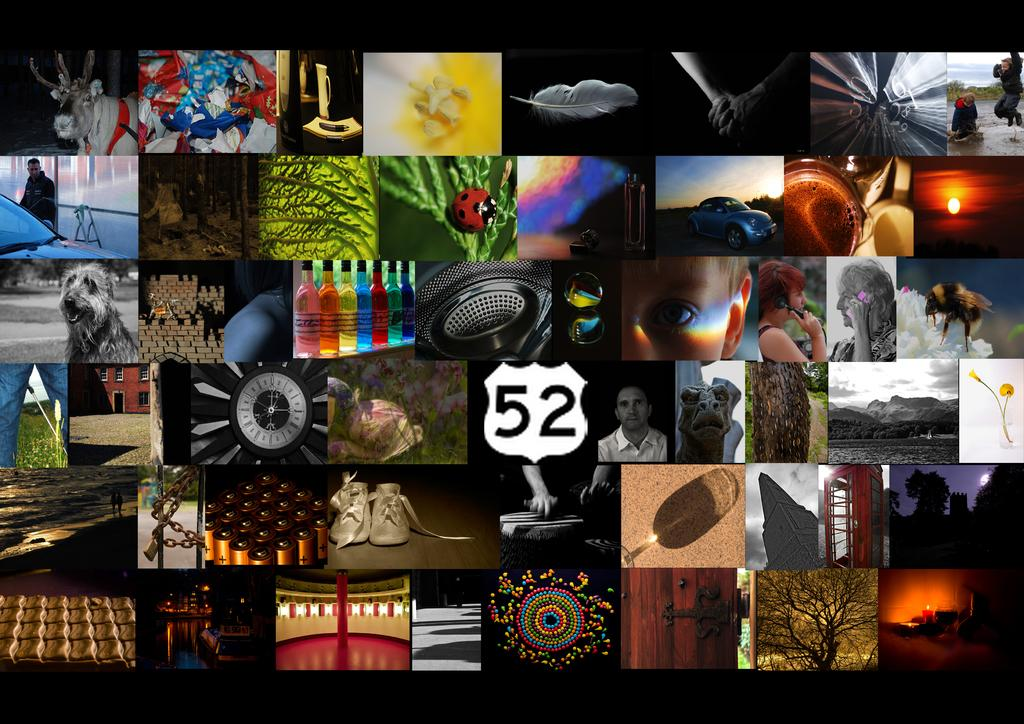Provide a one-sentence caption for the provided image. a large photograph with tons of different pictures. 